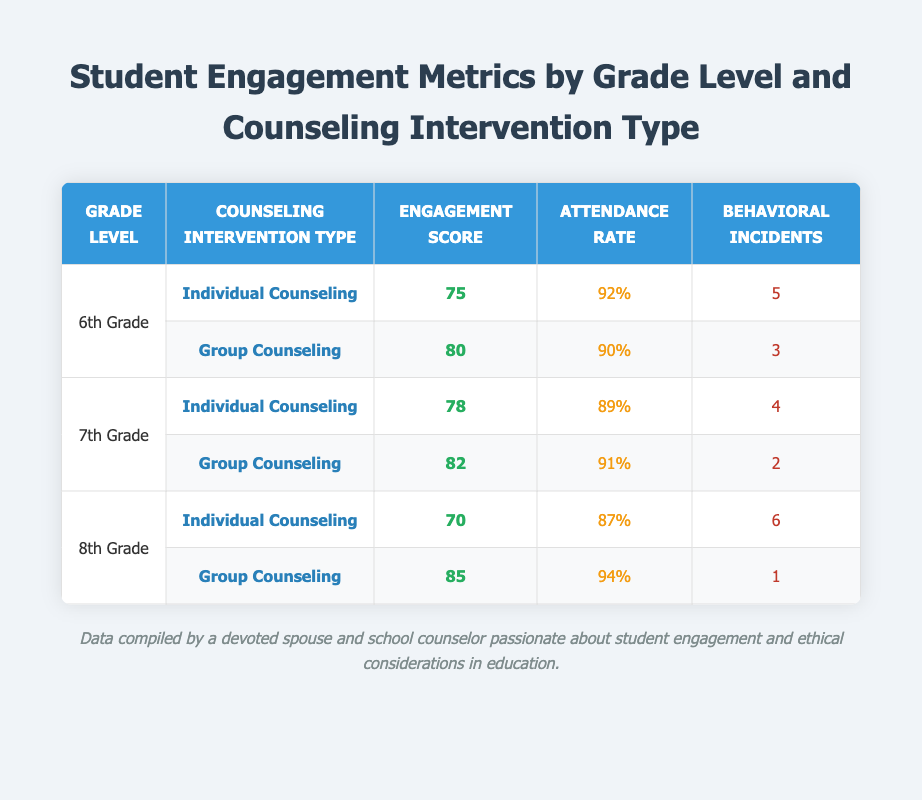What is the engagement score for 7th Grade Group Counseling? The engagement score for 7th Grade Group Counseling can be found in the table under the "7th Grade" and "Group Counseling" rows. It shows an engagement score of 82.
Answer: 82 What is the attendance rate for 6th Grade Individual Counseling? The attendance rate for 6th Grade Individual Counseling is listed in the table next to the respective row, which indicates an attendance rate of 92%.
Answer: 92% How many behavioral incidents were reported for 8th Grade Group Counseling? By looking at the row for 8th Grade Group Counseling, the table provides the number of behavioral incidents, which is noted as 1.
Answer: 1 What is the average engagement score for all grades in Group Counseling? To find the average engagement score for Group Counseling, first identify the engagement scores for each grade. They are 80 (6th Grade), 82 (7th Grade), and 85 (8th Grade). The sum of these scores is 80 + 82 + 85 = 247. There are 3 grades, so the average is 247 / 3 = 82.33.
Answer: 82.33 Is the attendance rate higher for 8th Grade Individual Counseling compared to 7th Grade Individual Counseling? The attendance rates for both types of counseling need to be compared. From the table, 8th Grade Individual Counseling has an attendance rate of 87%, while 7th Grade Individual Counseling has an attendance rate of 89%. Since 87% is less than 89%, the statement is false.
Answer: No What is the total number of behavioral incidents for 6th Grade students across both types of counseling? To calculate this, add the behavioral incidents for both types of counseling for 6th Grade. The incidents for Individual Counseling are 5, and for Group Counseling, they are 3. Therefore, the total is 5 + 3 = 8.
Answer: 8 Which grade level has the highest attendance rate in Group Counseling? Look through the table for the attendance rates in Group Counseling for each grade. The rates are 90% for 6th Grade, 91% for 7th Grade, and 94% for 8th Grade. Since 94% is the highest, the 8th Grade has the highest attendance rate in Group Counseling.
Answer: 8th Grade Did 7th Grade have fewer behavioral incidents in Group Counseling compared to 6th Grade? From the table, the 7th Grade Group Counseling had 2 behavioral incidents, while the 6th Grade Group Counseling had 3. Since 2 is fewer than 3, the statement is true.
Answer: Yes What is the engagement score difference between 8th Grade Group Counseling and 6th Grade Individual Counseling? The engagement score for 8th Grade Group Counseling is 85, and for 6th Grade Individual Counseling, it is 75. To find the difference, subtract the lower score from the higher score: 85 - 75 = 10.
Answer: 10 